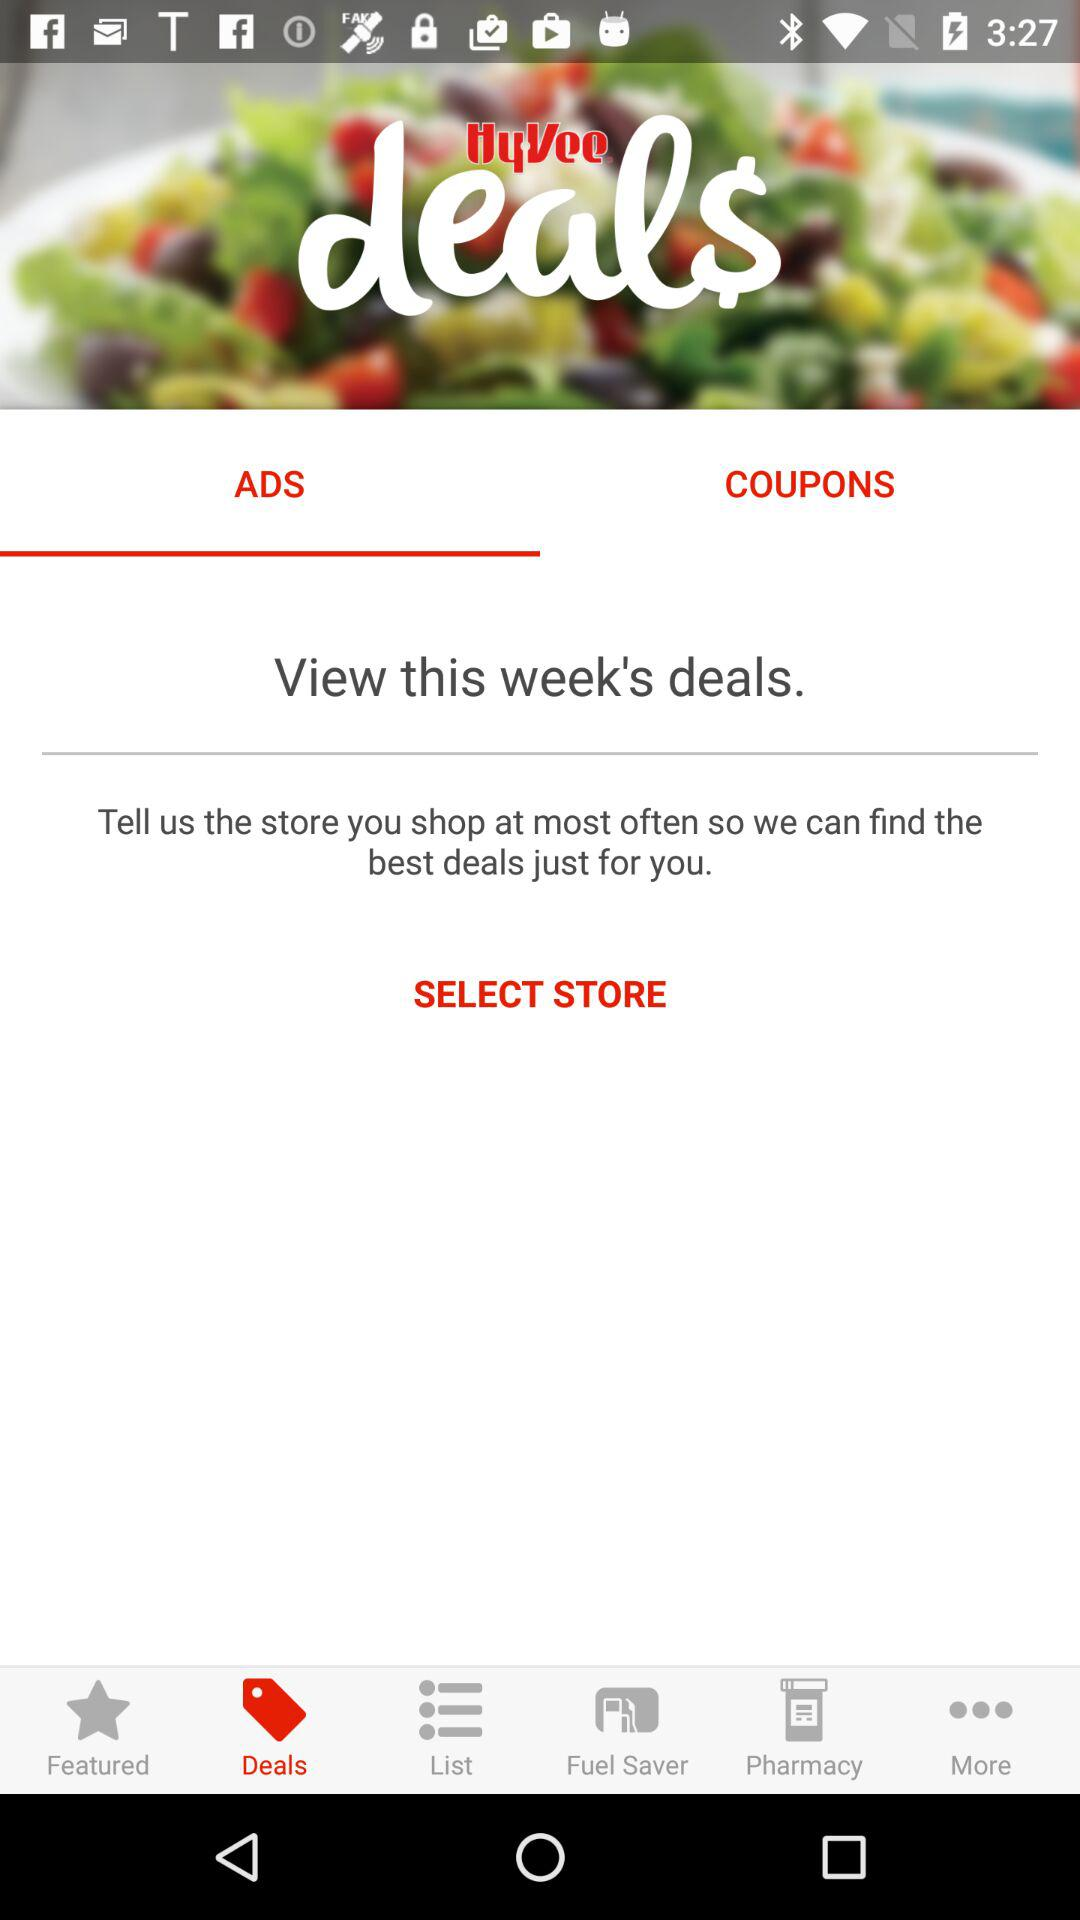How many coupons are available?
When the provided information is insufficient, respond with <no answer>. <no answer> 